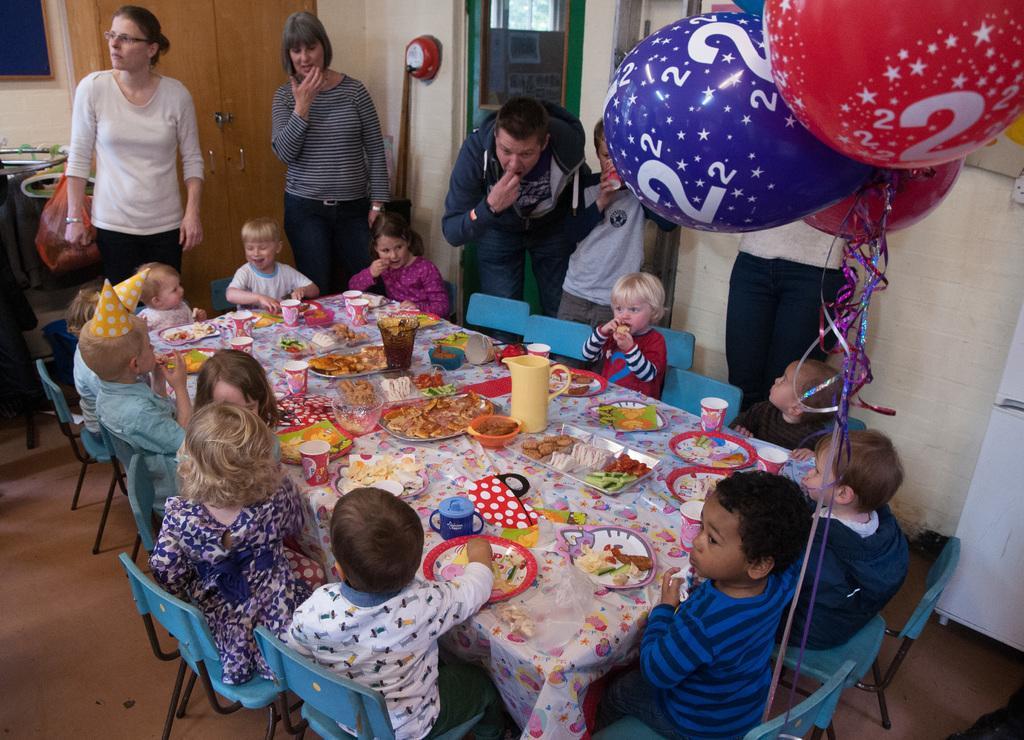Please provide a concise description of this image. In the center of the image there is a table and we can see plates, bottles, jars, bowls and some food placed on the table. There are kids sitting around the tables. In the background there are people standing. We can see balloons, door and a wall. 